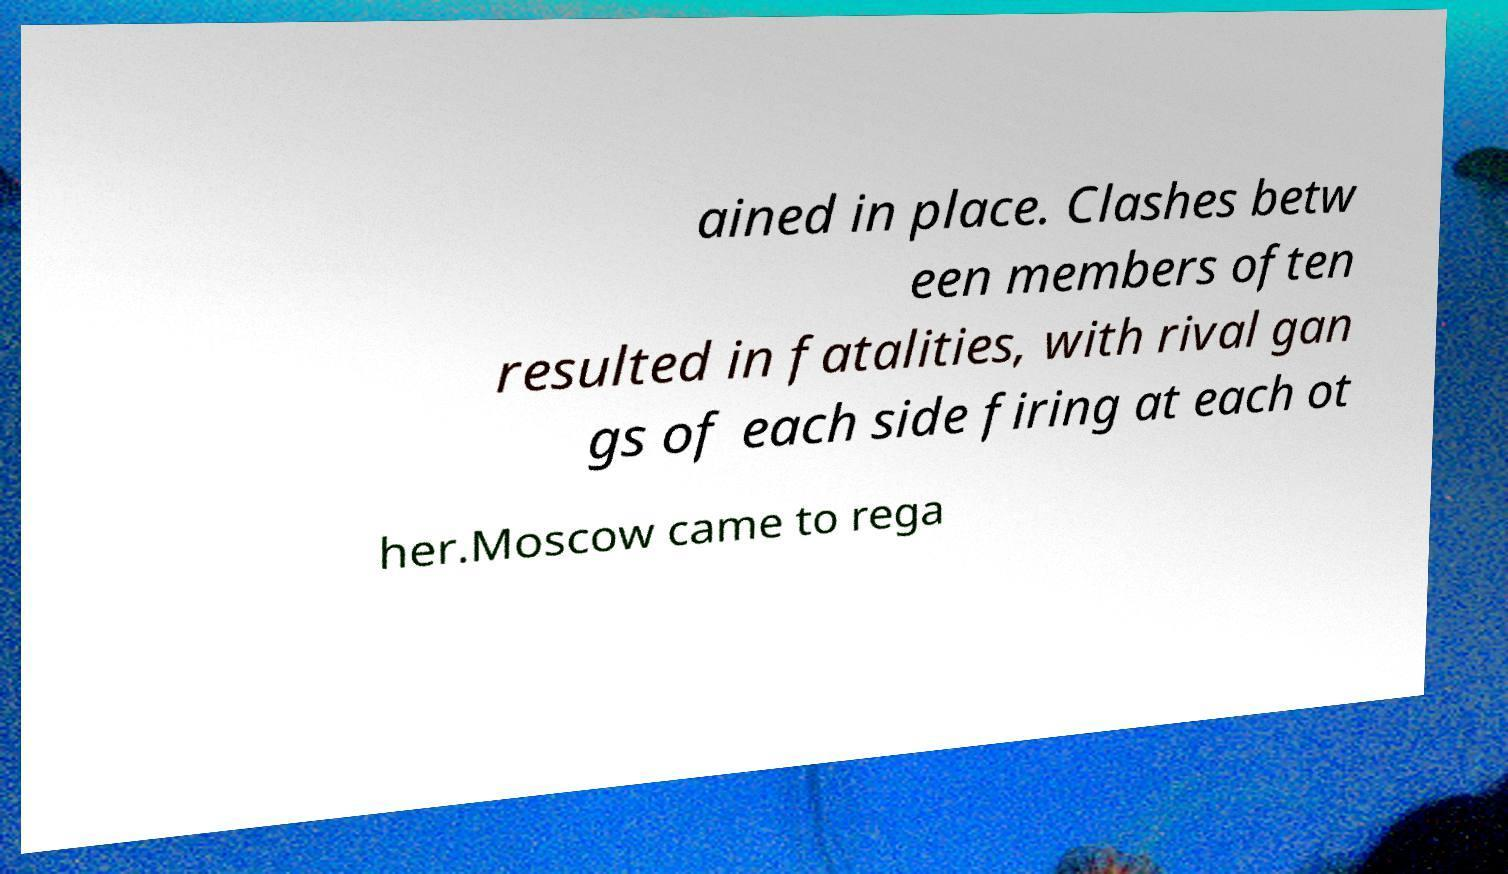I need the written content from this picture converted into text. Can you do that? ained in place. Clashes betw een members often resulted in fatalities, with rival gan gs of each side firing at each ot her.Moscow came to rega 